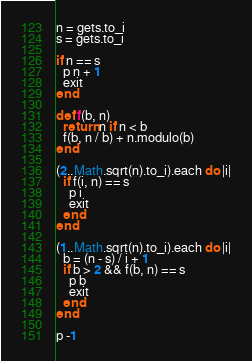Convert code to text. <code><loc_0><loc_0><loc_500><loc_500><_Ruby_>n = gets.to_i
s = gets.to_i

if n == s
  p n + 1
  exit
end

def f(b, n)
  return n if n < b
  f(b, n / b) + n.modulo(b)
end

(2..Math.sqrt(n).to_i).each do |i|
  if f(i, n) == s
    p i
    exit
  end
end

(1..Math.sqrt(n).to_i).each do |i|
  b = (n - s) / i + 1
  if b > 2 && f(b, n) == s
    p b
    exit
  end
end

p -1
</code> 